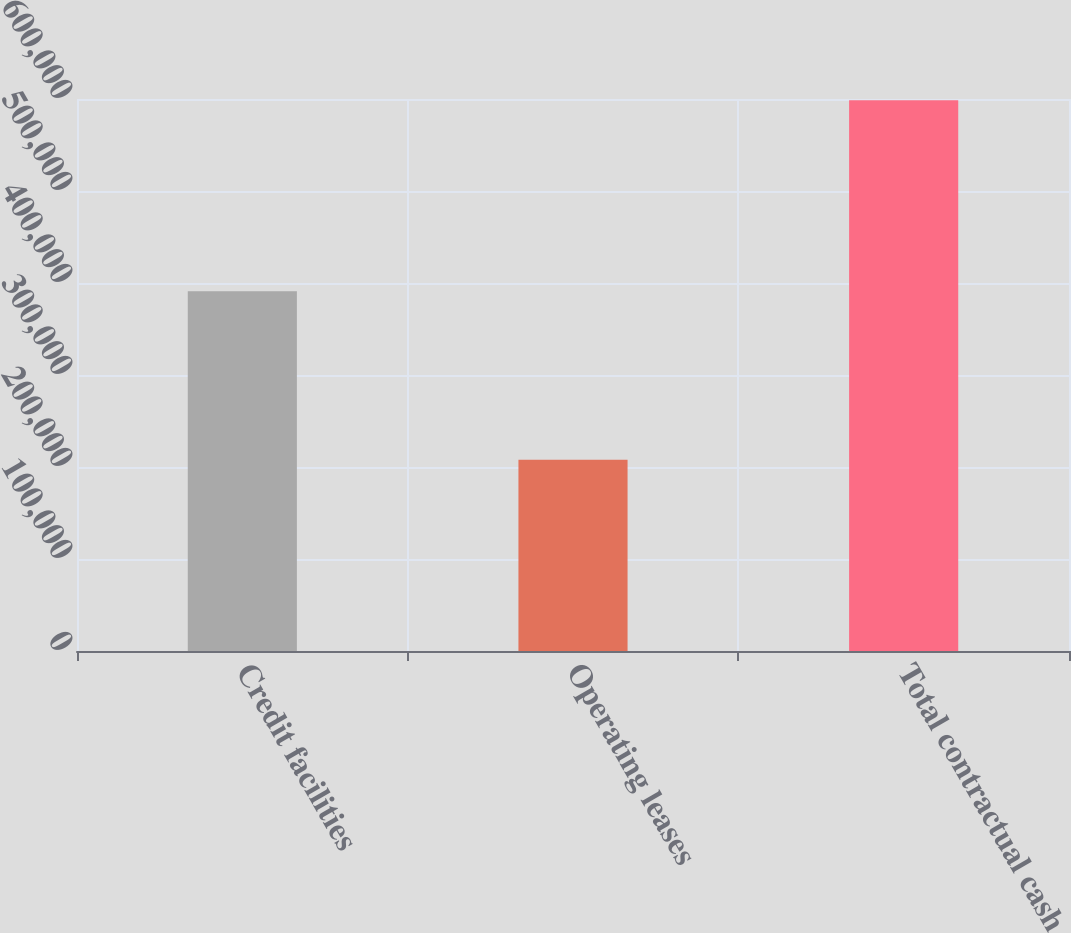Convert chart. <chart><loc_0><loc_0><loc_500><loc_500><bar_chart><fcel>Credit facilities<fcel>Operating leases<fcel>Total contractual cash<nl><fcel>390900<fcel>207800<fcel>598700<nl></chart> 